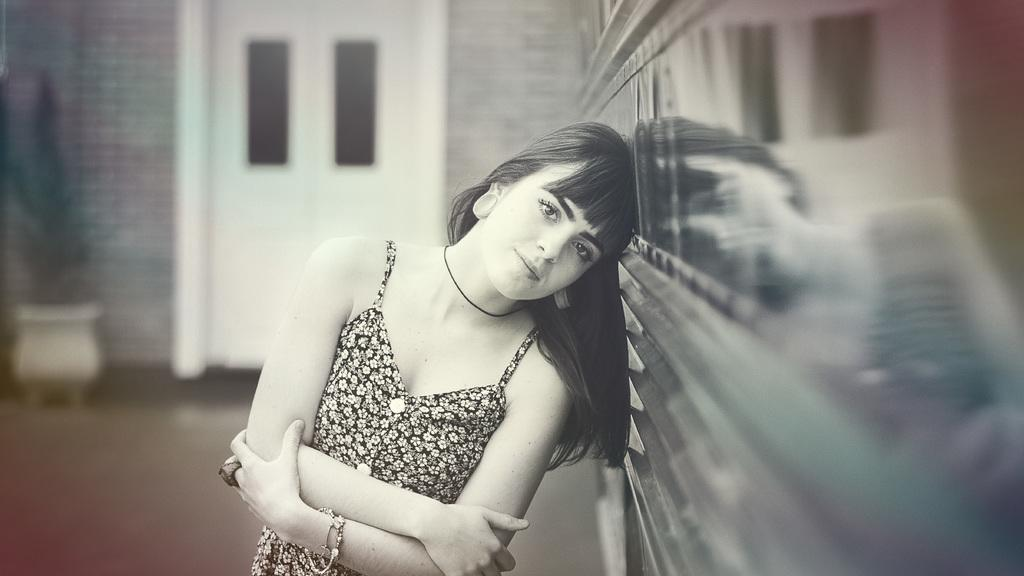Who is present in the image? There is a woman in the image. What is the woman doing in the image? The woman is standing. What is the woman wearing in the image? The woman is wearing a black floral dress. What can be seen on the right side of the image? There is a wall on the right side of the image. What is visible in the background of the image? There is a door and a plant in the background of the image. What type of dinosaur can be seen comfortably sitting on the woman's shoulder in the image? There are no dinosaurs present in the image, and the woman is not shown to be in any discomfort. 